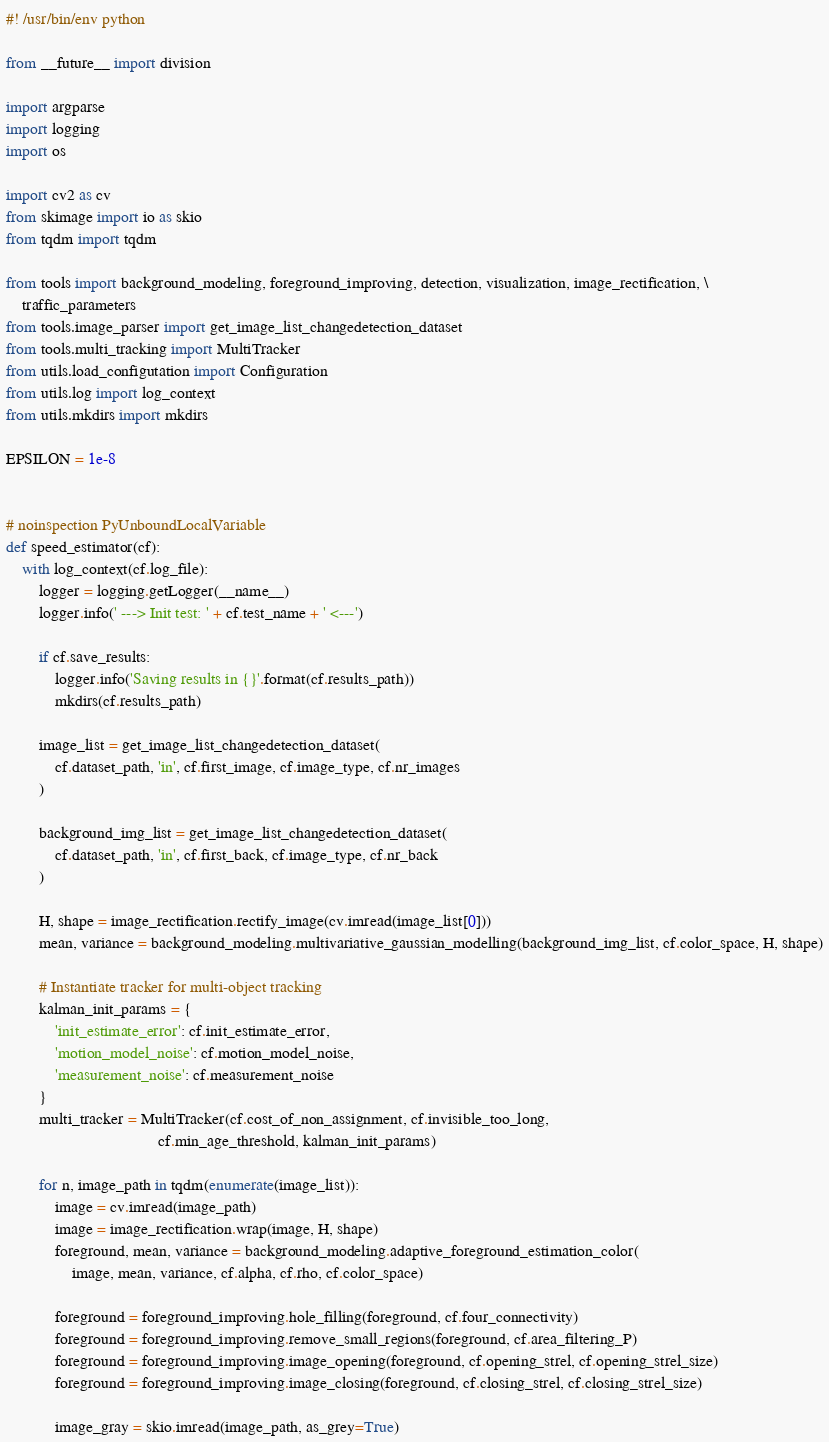<code> <loc_0><loc_0><loc_500><loc_500><_Python_>#! /usr/bin/env python

from __future__ import division

import argparse
import logging
import os

import cv2 as cv
from skimage import io as skio
from tqdm import tqdm

from tools import background_modeling, foreground_improving, detection, visualization, image_rectification, \
    traffic_parameters
from tools.image_parser import get_image_list_changedetection_dataset
from tools.multi_tracking import MultiTracker
from utils.load_configutation import Configuration
from utils.log import log_context
from utils.mkdirs import mkdirs

EPSILON = 1e-8


# noinspection PyUnboundLocalVariable
def speed_estimator(cf):
    with log_context(cf.log_file):
        logger = logging.getLogger(__name__)
        logger.info(' ---> Init test: ' + cf.test_name + ' <---')

        if cf.save_results:
            logger.info('Saving results in {}'.format(cf.results_path))
            mkdirs(cf.results_path)

        image_list = get_image_list_changedetection_dataset(
            cf.dataset_path, 'in', cf.first_image, cf.image_type, cf.nr_images
        )

        background_img_list = get_image_list_changedetection_dataset(
            cf.dataset_path, 'in', cf.first_back, cf.image_type, cf.nr_back
        )

        H, shape = image_rectification.rectify_image(cv.imread(image_list[0]))
        mean, variance = background_modeling.multivariative_gaussian_modelling(background_img_list, cf.color_space, H, shape)

        # Instantiate tracker for multi-object tracking
        kalman_init_params = {
            'init_estimate_error': cf.init_estimate_error,
            'motion_model_noise': cf.motion_model_noise,
            'measurement_noise': cf.measurement_noise
        }
        multi_tracker = MultiTracker(cf.cost_of_non_assignment, cf.invisible_too_long,
                                     cf.min_age_threshold, kalman_init_params)

        for n, image_path in tqdm(enumerate(image_list)):
            image = cv.imread(image_path)
            image = image_rectification.wrap(image, H, shape)
            foreground, mean, variance = background_modeling.adaptive_foreground_estimation_color(
                image, mean, variance, cf.alpha, cf.rho, cf.color_space)

            foreground = foreground_improving.hole_filling(foreground, cf.four_connectivity)
            foreground = foreground_improving.remove_small_regions(foreground, cf.area_filtering_P)
            foreground = foreground_improving.image_opening(foreground, cf.opening_strel, cf.opening_strel_size)
            foreground = foreground_improving.image_closing(foreground, cf.closing_strel, cf.closing_strel_size)

            image_gray = skio.imread(image_path, as_grey=True)</code> 